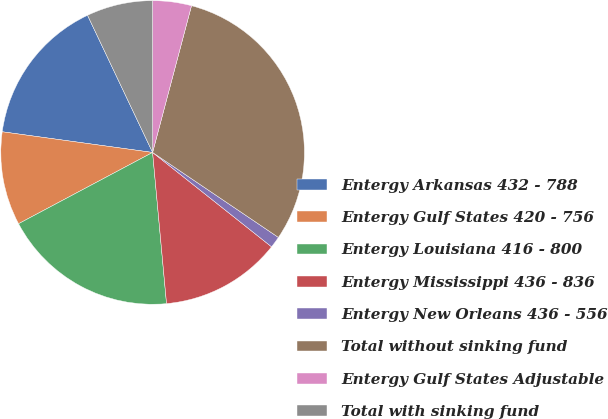Convert chart. <chart><loc_0><loc_0><loc_500><loc_500><pie_chart><fcel>Entergy Arkansas 432 - 788<fcel>Entergy Gulf States 420 - 756<fcel>Entergy Louisiana 416 - 800<fcel>Entergy Mississippi 436 - 836<fcel>Entergy New Orleans 436 - 556<fcel>Total without sinking fund<fcel>Entergy Gulf States Adjustable<fcel>Total with sinking fund<nl><fcel>15.77%<fcel>9.95%<fcel>18.68%<fcel>12.86%<fcel>1.22%<fcel>30.32%<fcel>4.13%<fcel>7.04%<nl></chart> 